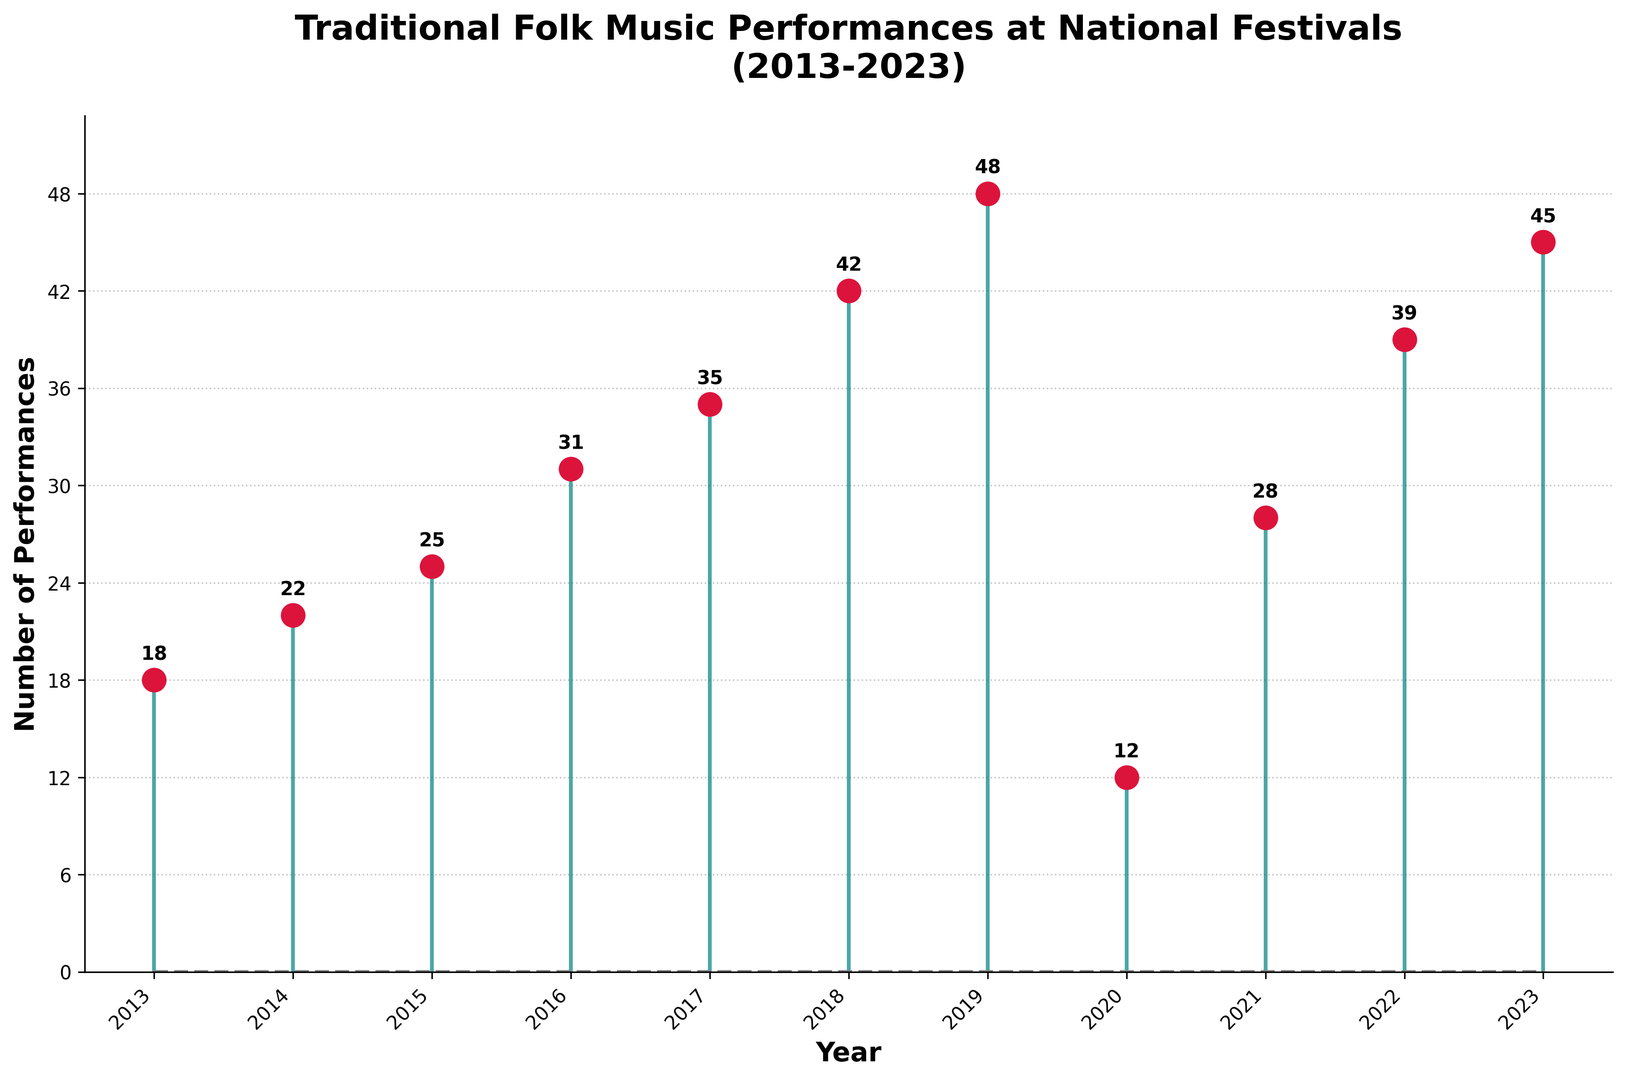How many traditional folk music performances were observed in 2020? Look at the data point corresponding to the year 2020 on the plot; the value is 12.
Answer: 12 Which year had the highest number of traditional folk music performances? Observe the y-values on the plot and identify the year with the highest height bar; 2019 holds the highest performance count of 48 performances.
Answer: 2019 By how much did the performances increase from 2018 to 2019? Compare the performance counts for 2018 and 2019 (48 - 42), noting that 48 is 6 more than 42.
Answer: 6 What is the overall trend in the number of traditional folk music performances from 2013 to 2023? Analyze the plot line from 2013 to 2023 to see if the general movement is upward or downward; the plot shows a rising trend with slight fluctuations.
Answer: Upward trend Which year experienced the largest drop in the number of performances compared to the previous year? Identify the largest negative difference between consecutive years by comparing the performance numbers; from 2019 (48) to 2020 (12) is the largest drop of 36.
Answer: 2020 How many more performances were there in 2023 compared to 2013? Subtract the performance number for 2013 (18) from that for 2023 (45); (45 - 18) = 27.
Answer: 27 What was the percentage increase in performances from 2014 to 2015? Calculate the percentage increase using the formula ((25 - 22) / 22) * 100; the increase from 22 performances to 25 performances is approximately 13.64%.
Answer: 13.64% Is there a year with the same number of performances as another year? Scan the plot for y-values that are identical; no two years have the same number of performances.
Answer: No Between which consecutive years did the number of performances increase the most? Compare the difference between consecutive years and identify the largest positive difference; the difference between 2018 (42) and 2019 (48) is the largest at 6.
Answer: 2018 to 2019 By what percentage did the performances decrease from 2019 to 2020? Calculate the percentage decrease using the formula ((48 - 12) / 48) * 100; the decrease is 75%.
Answer: 75% 